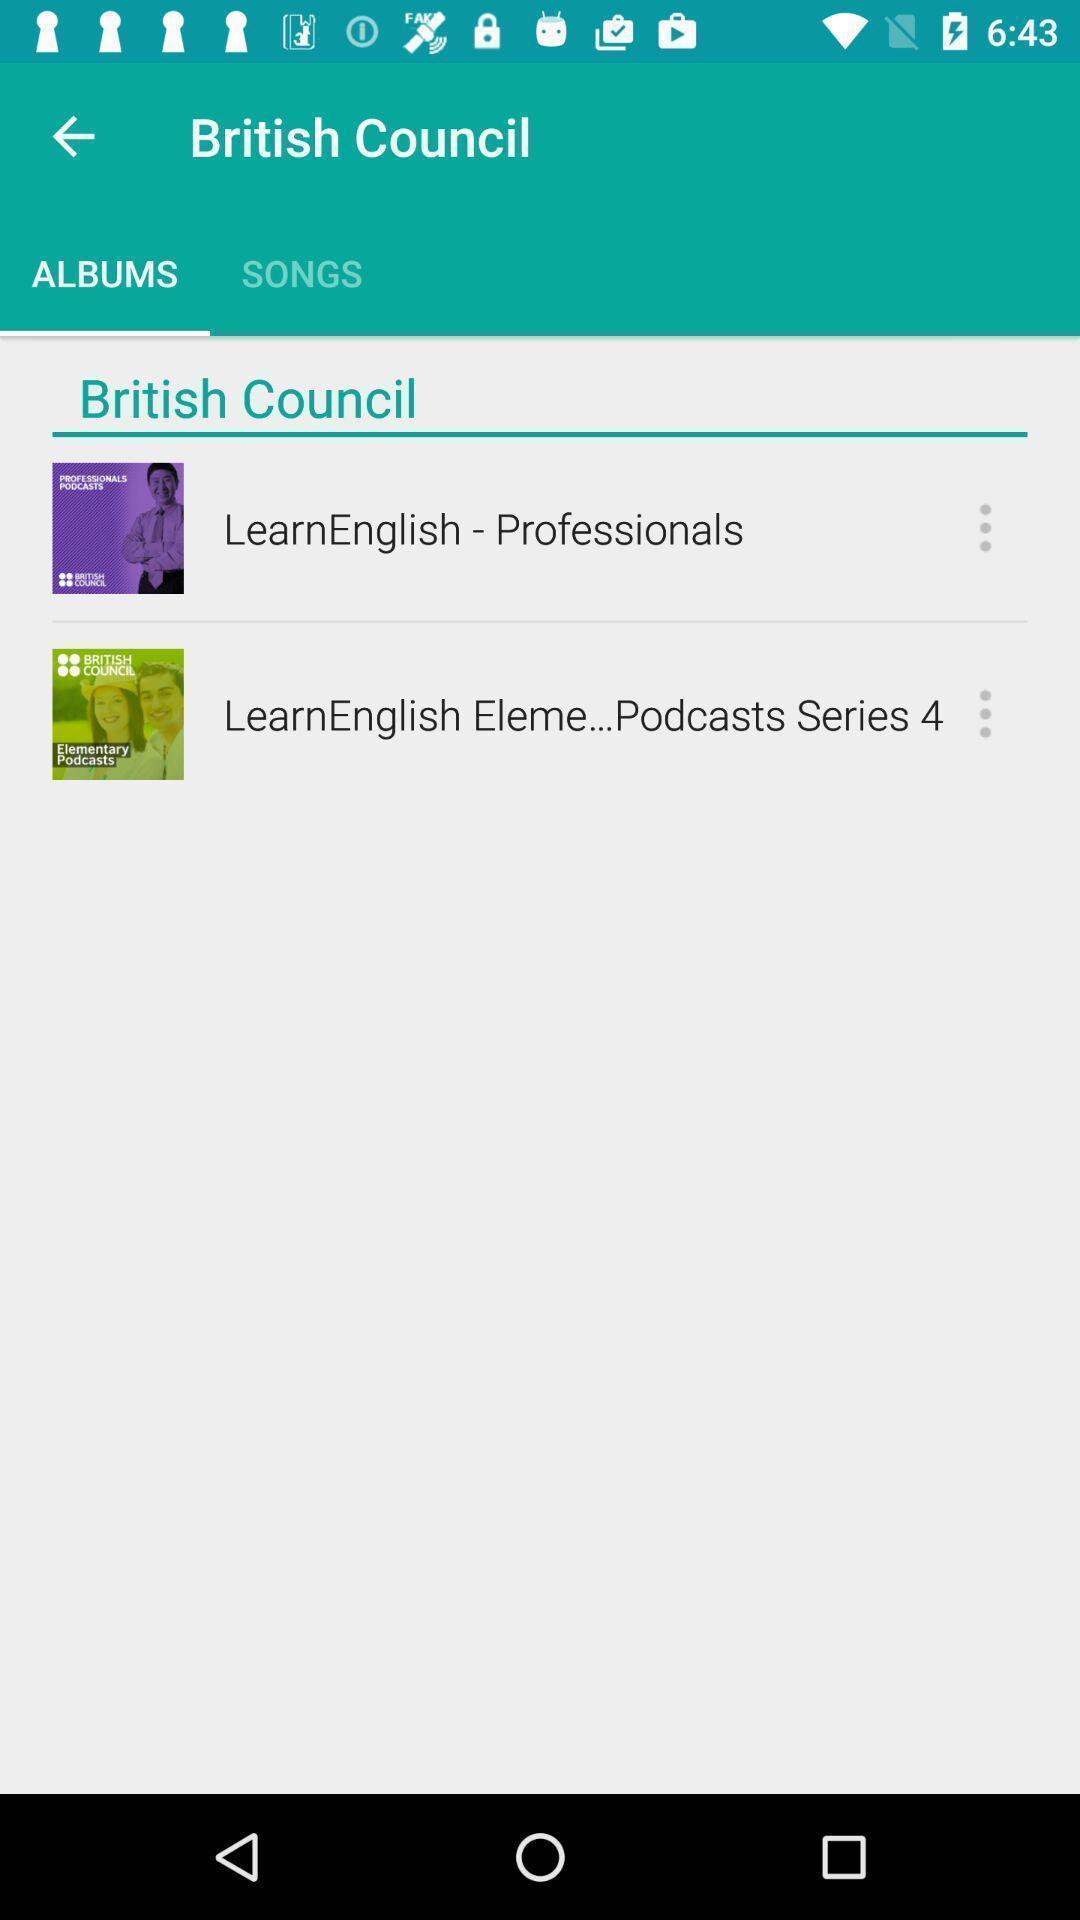Tell me what you see in this picture. Various media list displayed. 